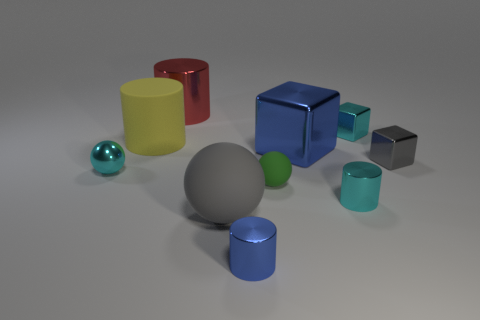Subtract all tiny cyan cylinders. How many cylinders are left? 3 Subtract all cyan spheres. How many spheres are left? 2 Subtract 2 balls. How many balls are left? 1 Subtract all green cylinders. Subtract all blue spheres. How many cylinders are left? 4 Add 5 tiny cyan metal cylinders. How many tiny cyan metal cylinders exist? 6 Subtract 0 brown cylinders. How many objects are left? 10 Subtract all cubes. How many objects are left? 7 Subtract all tiny blue metallic cylinders. Subtract all matte things. How many objects are left? 6 Add 9 large red shiny cylinders. How many large red shiny cylinders are left? 10 